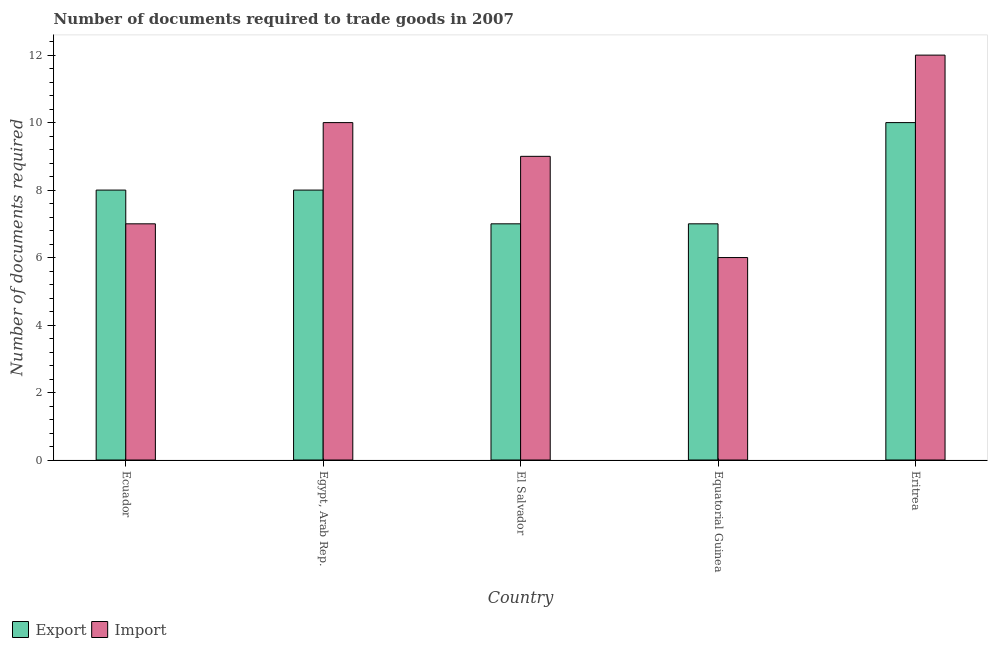How many groups of bars are there?
Provide a succinct answer. 5. What is the label of the 5th group of bars from the left?
Your answer should be very brief. Eritrea. Across all countries, what is the minimum number of documents required to export goods?
Your answer should be very brief. 7. In which country was the number of documents required to export goods maximum?
Keep it short and to the point. Eritrea. In which country was the number of documents required to export goods minimum?
Keep it short and to the point. El Salvador. What is the average number of documents required to export goods per country?
Make the answer very short. 8. In how many countries, is the number of documents required to export goods greater than 8.4 ?
Your response must be concise. 1. Is the difference between the number of documents required to export goods in Ecuador and Egypt, Arab Rep. greater than the difference between the number of documents required to import goods in Ecuador and Egypt, Arab Rep.?
Your answer should be compact. Yes. What is the difference between the highest and the lowest number of documents required to import goods?
Make the answer very short. 6. What does the 1st bar from the left in Equatorial Guinea represents?
Your answer should be very brief. Export. What does the 2nd bar from the right in El Salvador represents?
Ensure brevity in your answer.  Export. Are all the bars in the graph horizontal?
Keep it short and to the point. No. What is the difference between two consecutive major ticks on the Y-axis?
Provide a succinct answer. 2. Are the values on the major ticks of Y-axis written in scientific E-notation?
Your response must be concise. No. Where does the legend appear in the graph?
Offer a very short reply. Bottom left. How many legend labels are there?
Offer a terse response. 2. How are the legend labels stacked?
Give a very brief answer. Horizontal. What is the title of the graph?
Your response must be concise. Number of documents required to trade goods in 2007. Does "Commercial bank branches" appear as one of the legend labels in the graph?
Your answer should be very brief. No. What is the label or title of the X-axis?
Your response must be concise. Country. What is the label or title of the Y-axis?
Make the answer very short. Number of documents required. What is the Number of documents required of Import in Ecuador?
Your answer should be very brief. 7. What is the Number of documents required of Export in Egypt, Arab Rep.?
Provide a short and direct response. 8. What is the Number of documents required in Import in Egypt, Arab Rep.?
Make the answer very short. 10. What is the Number of documents required of Export in El Salvador?
Provide a short and direct response. 7. What is the Number of documents required in Import in Equatorial Guinea?
Give a very brief answer. 6. What is the Number of documents required of Import in Eritrea?
Offer a very short reply. 12. Across all countries, what is the maximum Number of documents required in Export?
Offer a terse response. 10. What is the total Number of documents required in Export in the graph?
Your answer should be very brief. 40. What is the total Number of documents required of Import in the graph?
Keep it short and to the point. 44. What is the difference between the Number of documents required in Export in Ecuador and that in El Salvador?
Offer a very short reply. 1. What is the difference between the Number of documents required of Import in Ecuador and that in Equatorial Guinea?
Ensure brevity in your answer.  1. What is the difference between the Number of documents required of Import in Ecuador and that in Eritrea?
Your response must be concise. -5. What is the difference between the Number of documents required of Import in Egypt, Arab Rep. and that in El Salvador?
Offer a very short reply. 1. What is the difference between the Number of documents required in Import in Egypt, Arab Rep. and that in Equatorial Guinea?
Make the answer very short. 4. What is the difference between the Number of documents required of Export in Egypt, Arab Rep. and that in Eritrea?
Keep it short and to the point. -2. What is the difference between the Number of documents required of Export in El Salvador and that in Equatorial Guinea?
Offer a terse response. 0. What is the difference between the Number of documents required of Import in El Salvador and that in Equatorial Guinea?
Offer a very short reply. 3. What is the difference between the Number of documents required of Export in El Salvador and that in Eritrea?
Your answer should be compact. -3. What is the difference between the Number of documents required in Export in Equatorial Guinea and that in Eritrea?
Your answer should be compact. -3. What is the difference between the Number of documents required of Export in Ecuador and the Number of documents required of Import in Egypt, Arab Rep.?
Your response must be concise. -2. What is the difference between the Number of documents required of Export in Ecuador and the Number of documents required of Import in Equatorial Guinea?
Give a very brief answer. 2. What is the difference between the Number of documents required in Export in Ecuador and the Number of documents required in Import in Eritrea?
Provide a short and direct response. -4. What is the difference between the Number of documents required of Export in Egypt, Arab Rep. and the Number of documents required of Import in El Salvador?
Ensure brevity in your answer.  -1. What is the difference between the Number of documents required in Export in Egypt, Arab Rep. and the Number of documents required in Import in Eritrea?
Provide a succinct answer. -4. What is the difference between the Number of documents required in Export in El Salvador and the Number of documents required in Import in Equatorial Guinea?
Offer a terse response. 1. What is the difference between the Number of documents required in Export in Equatorial Guinea and the Number of documents required in Import in Eritrea?
Your answer should be very brief. -5. What is the average Number of documents required of Import per country?
Your answer should be very brief. 8.8. What is the difference between the Number of documents required of Export and Number of documents required of Import in Ecuador?
Offer a very short reply. 1. What is the difference between the Number of documents required in Export and Number of documents required in Import in El Salvador?
Your answer should be compact. -2. What is the difference between the Number of documents required of Export and Number of documents required of Import in Equatorial Guinea?
Provide a succinct answer. 1. What is the difference between the Number of documents required in Export and Number of documents required in Import in Eritrea?
Offer a very short reply. -2. What is the ratio of the Number of documents required in Export in Ecuador to that in Egypt, Arab Rep.?
Your answer should be compact. 1. What is the ratio of the Number of documents required of Export in Ecuador to that in El Salvador?
Your answer should be compact. 1.14. What is the ratio of the Number of documents required of Export in Ecuador to that in Equatorial Guinea?
Ensure brevity in your answer.  1.14. What is the ratio of the Number of documents required in Import in Ecuador to that in Eritrea?
Your response must be concise. 0.58. What is the ratio of the Number of documents required of Import in Egypt, Arab Rep. to that in El Salvador?
Make the answer very short. 1.11. What is the ratio of the Number of documents required of Export in Egypt, Arab Rep. to that in Equatorial Guinea?
Offer a terse response. 1.14. What is the ratio of the Number of documents required of Import in Egypt, Arab Rep. to that in Equatorial Guinea?
Ensure brevity in your answer.  1.67. What is the ratio of the Number of documents required in Export in Egypt, Arab Rep. to that in Eritrea?
Your answer should be compact. 0.8. What is the ratio of the Number of documents required in Export in El Salvador to that in Equatorial Guinea?
Your answer should be very brief. 1. What is the ratio of the Number of documents required of Export in El Salvador to that in Eritrea?
Offer a very short reply. 0.7. What is the ratio of the Number of documents required of Import in El Salvador to that in Eritrea?
Your response must be concise. 0.75. What is the ratio of the Number of documents required of Export in Equatorial Guinea to that in Eritrea?
Give a very brief answer. 0.7. What is the ratio of the Number of documents required in Import in Equatorial Guinea to that in Eritrea?
Provide a short and direct response. 0.5. What is the difference between the highest and the lowest Number of documents required in Export?
Offer a very short reply. 3. 